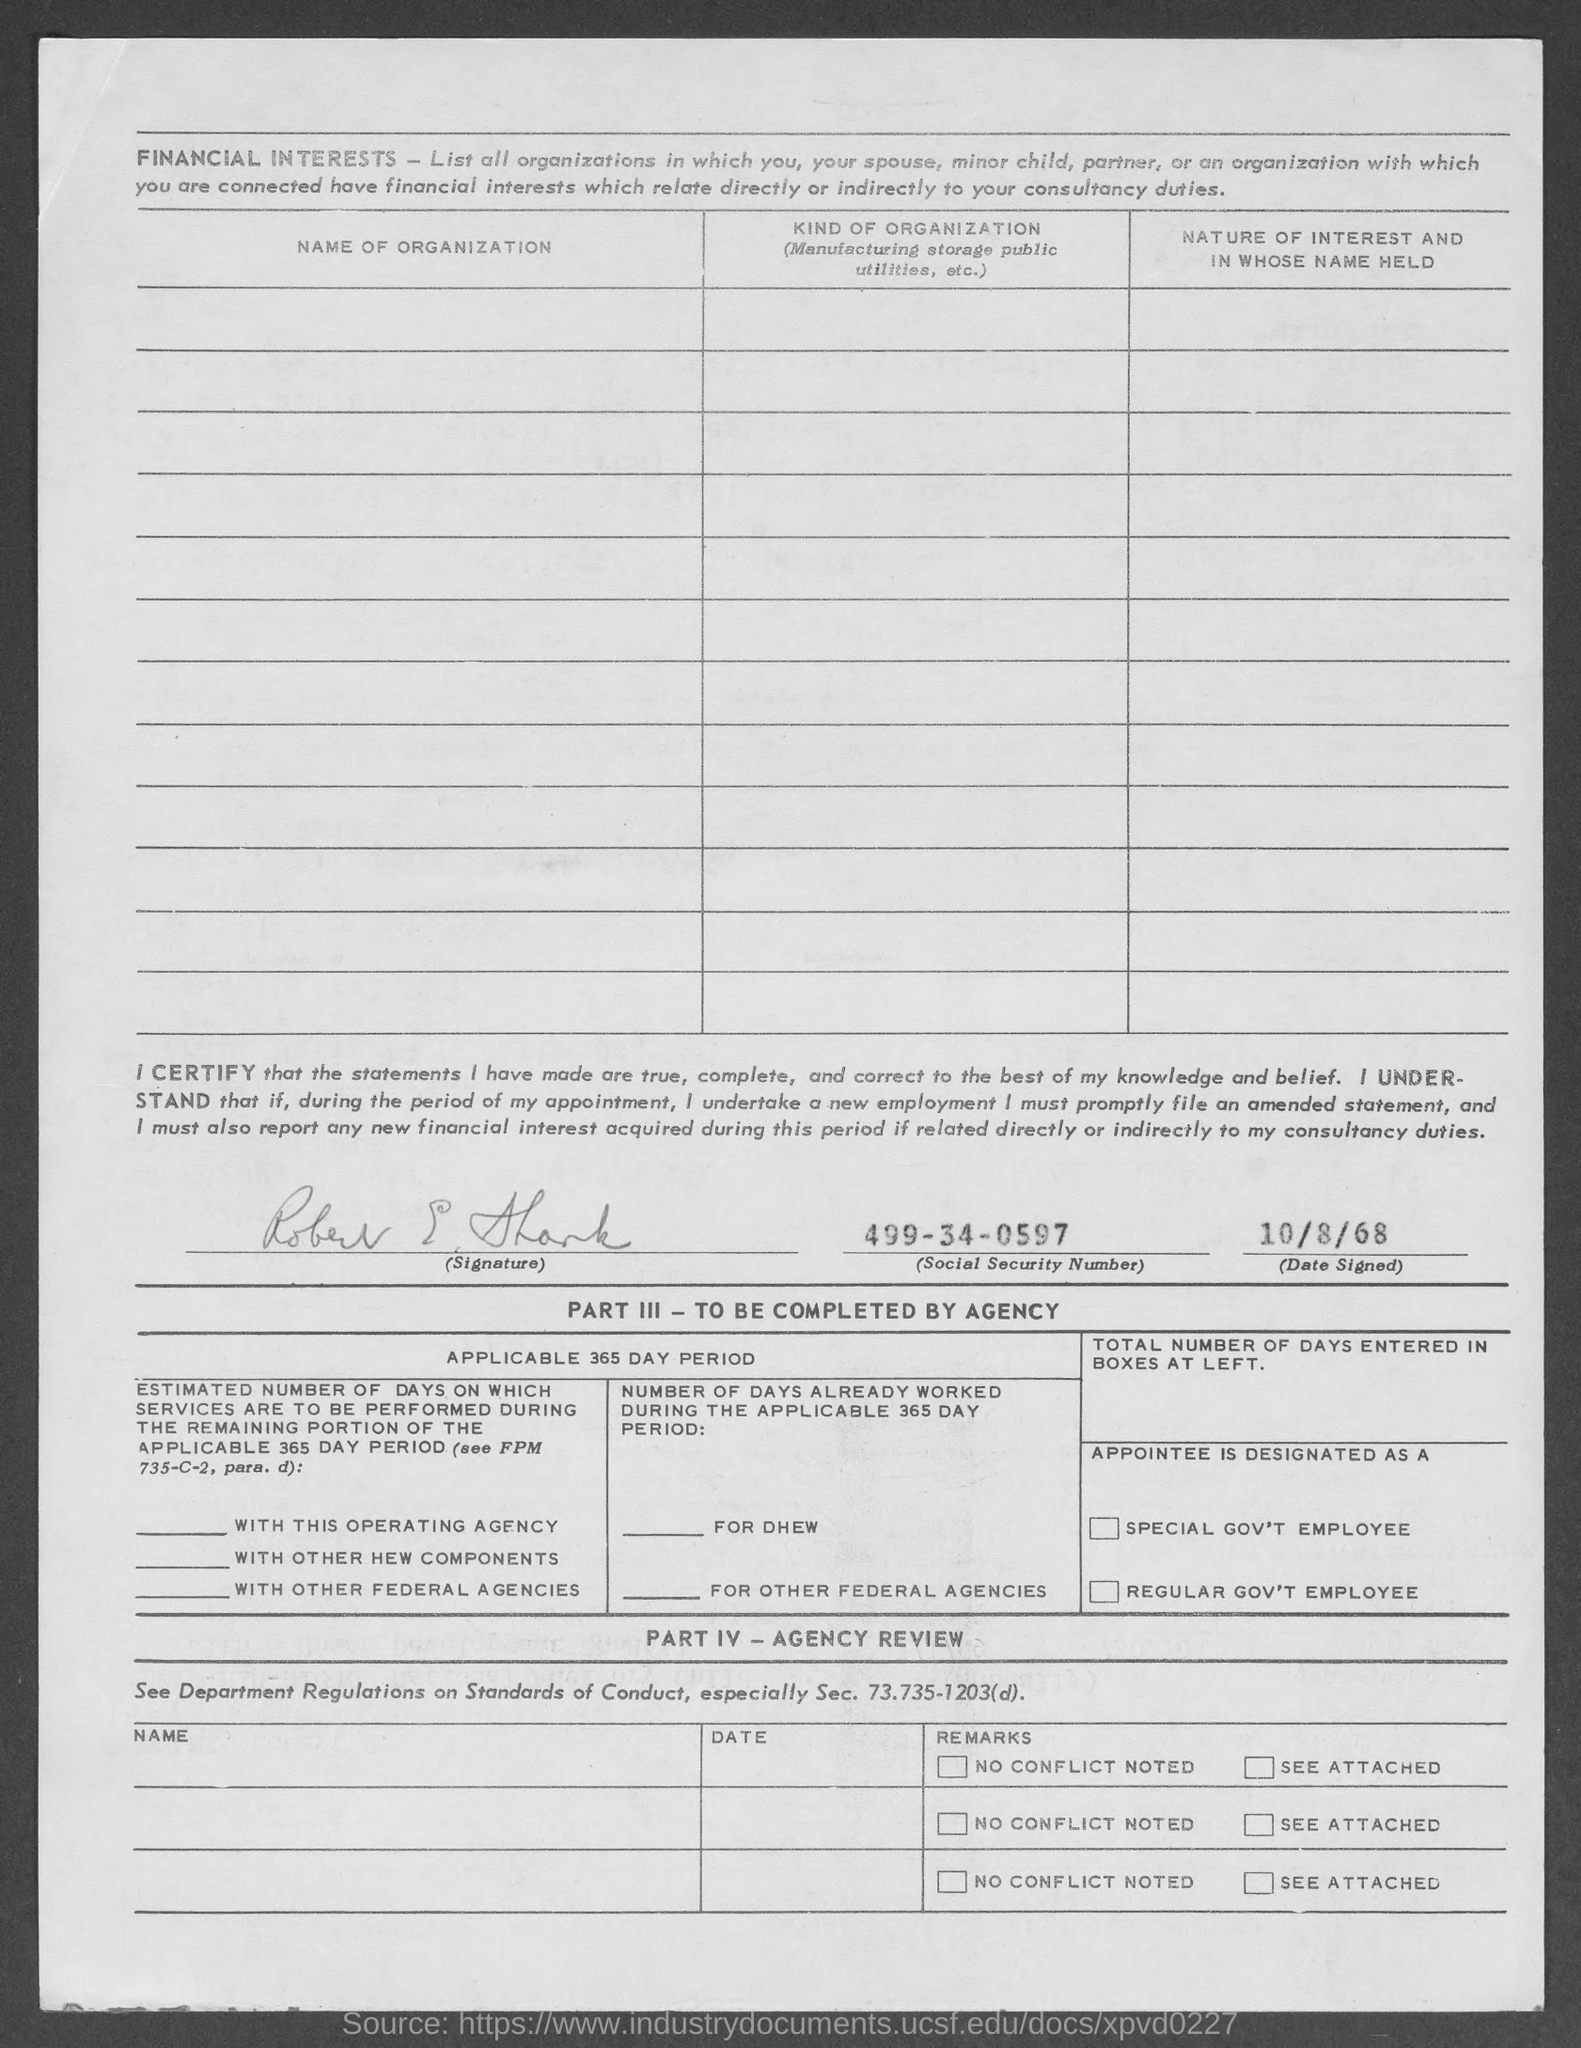Give some essential details in this illustration. The social security number provided in the document is 499-34-0597. 